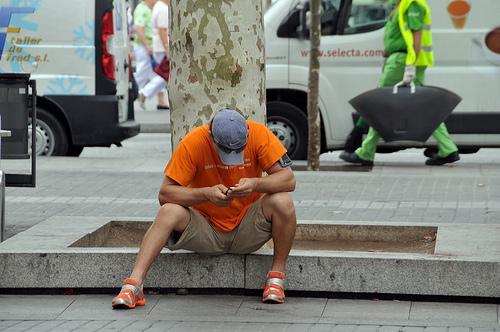What color is the man carrying the black bag wearing?
Answer briefly. Green. Where is he sitting?
Be succinct. Sidewalk. Can the man be hurt doing this?
Write a very short answer. No. What kind of hat is this person wearing?
Keep it brief. Baseball cap. How many people are wearing hats?
Quick response, please. 1. What's on the man's head?
Keep it brief. Hat. What number of men are sitting on the cement steps?
Keep it brief. 1. What color are the closest pair of shoes?
Concise answer only. Orange. 